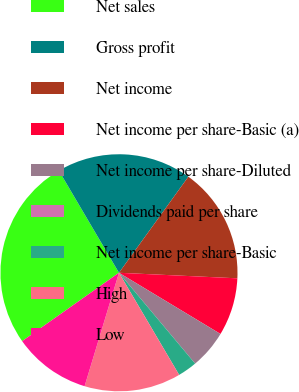<chart> <loc_0><loc_0><loc_500><loc_500><pie_chart><fcel>Net sales<fcel>Gross profit<fcel>Net income<fcel>Net income per share-Basic (a)<fcel>Net income per share-Diluted<fcel>Dividends paid per share<fcel>Net income per share-Basic<fcel>High<fcel>Low<nl><fcel>26.32%<fcel>18.42%<fcel>15.79%<fcel>7.89%<fcel>5.26%<fcel>0.0%<fcel>2.63%<fcel>13.16%<fcel>10.53%<nl></chart> 